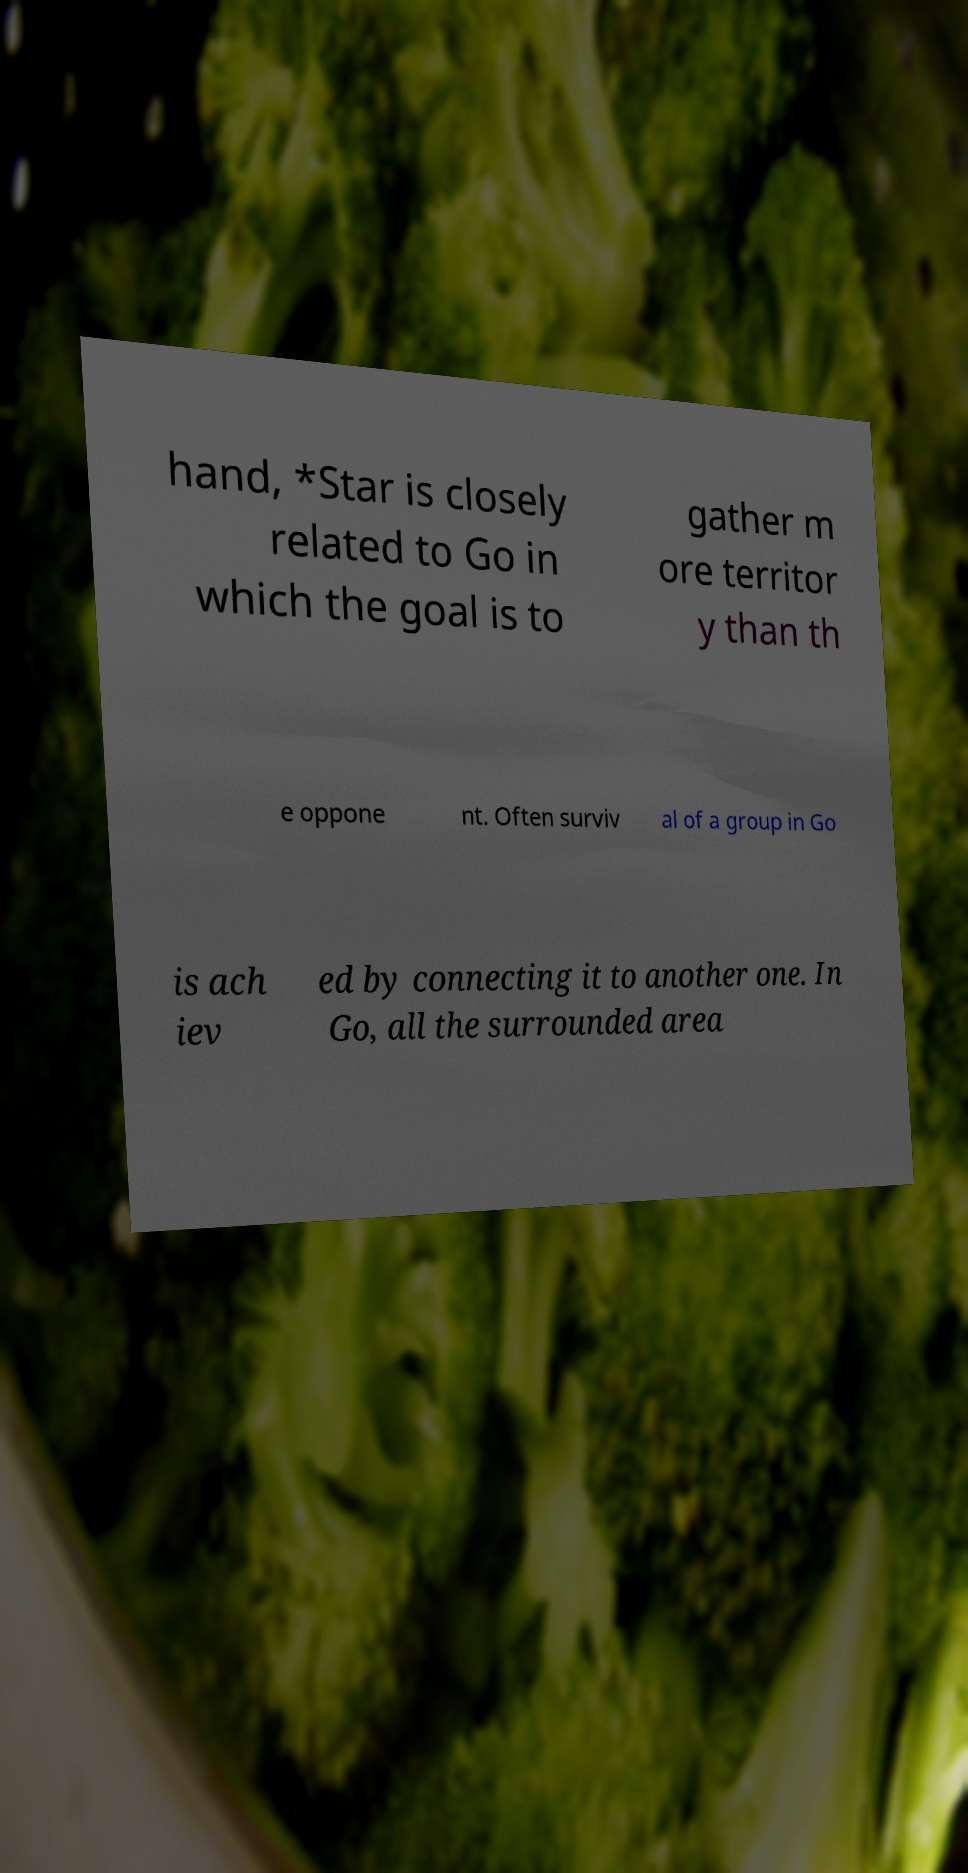Could you assist in decoding the text presented in this image and type it out clearly? hand, *Star is closely related to Go in which the goal is to gather m ore territor y than th e oppone nt. Often surviv al of a group in Go is ach iev ed by connecting it to another one. In Go, all the surrounded area 